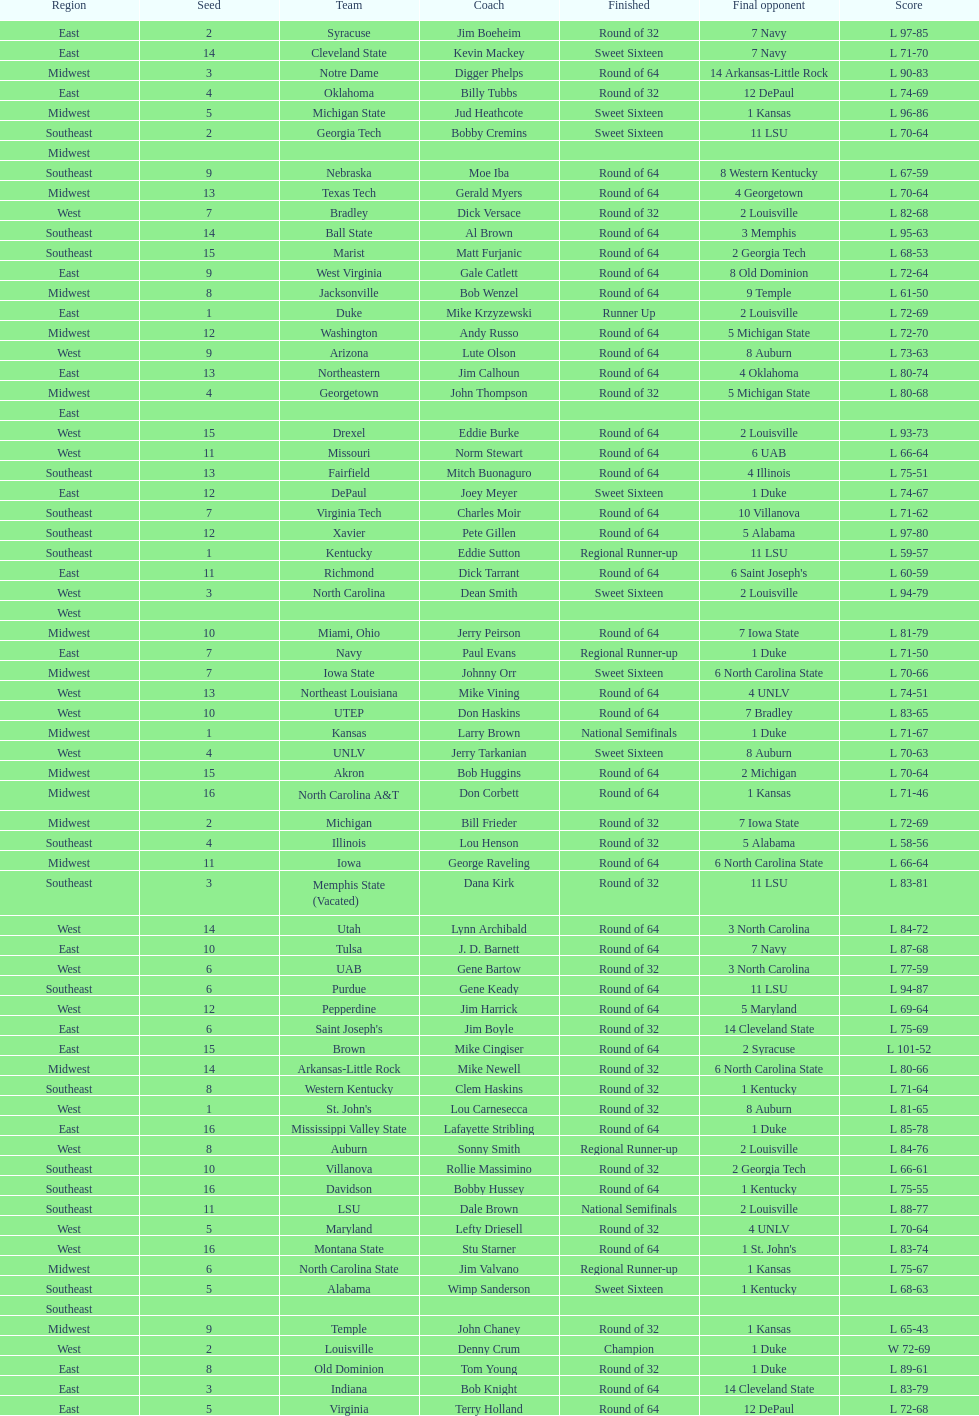Which zone is cited before the midwest? West. 